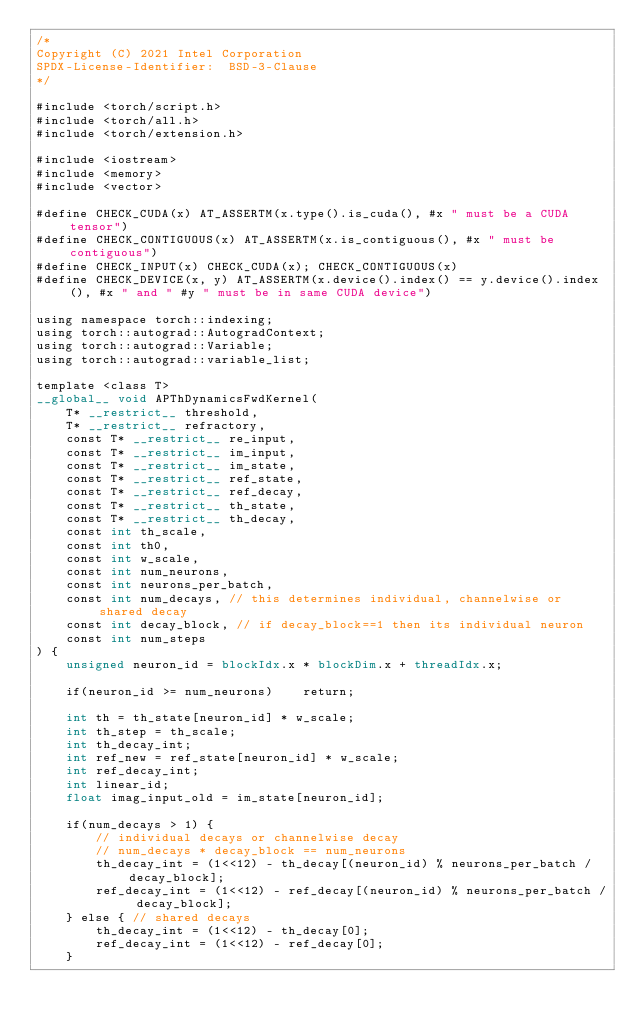Convert code to text. <code><loc_0><loc_0><loc_500><loc_500><_Cuda_>/*
Copyright (C) 2021 Intel Corporation
SPDX-License-Identifier:  BSD-3-Clause
*/

#include <torch/script.h>
#include <torch/all.h>
#include <torch/extension.h>

#include <iostream>
#include <memory>
#include <vector>

#define CHECK_CUDA(x) AT_ASSERTM(x.type().is_cuda(), #x " must be a CUDA tensor")
#define CHECK_CONTIGUOUS(x) AT_ASSERTM(x.is_contiguous(), #x " must be contiguous")
#define CHECK_INPUT(x) CHECK_CUDA(x); CHECK_CONTIGUOUS(x)
#define CHECK_DEVICE(x, y) AT_ASSERTM(x.device().index() == y.device().index(), #x " and " #y " must be in same CUDA device")

using namespace torch::indexing;
using torch::autograd::AutogradContext;
using torch::autograd::Variable;
using torch::autograd::variable_list;

template <class T>
__global__ void APThDynamicsFwdKernel(
    T* __restrict__ threshold,
    T* __restrict__ refractory,
    const T* __restrict__ re_input,
    const T* __restrict__ im_input,
    const T* __restrict__ im_state,
    const T* __restrict__ ref_state,
    const T* __restrict__ ref_decay,
    const T* __restrict__ th_state,
    const T* __restrict__ th_decay,
    const int th_scale,
    const int th0,
    const int w_scale,
    const int num_neurons,
    const int neurons_per_batch,
    const int num_decays, // this determines individual, channelwise or shared decay
    const int decay_block, // if decay_block==1 then its individual neuron
    const int num_steps
) {
    unsigned neuron_id = blockIdx.x * blockDim.x + threadIdx.x;

    if(neuron_id >= num_neurons)    return;

    int th = th_state[neuron_id] * w_scale;
    int th_step = th_scale;
    int th_decay_int;
    int ref_new = ref_state[neuron_id] * w_scale;
    int ref_decay_int;
    int linear_id; 
    float imag_input_old = im_state[neuron_id];

    if(num_decays > 1) {  
        // individual decays or channelwise decay
        // num_decays * decay_block == num_neurons
        th_decay_int = (1<<12) - th_decay[(neuron_id) % neurons_per_batch / decay_block];
        ref_decay_int = (1<<12) - ref_decay[(neuron_id) % neurons_per_batch / decay_block];
    } else { // shared decays
        th_decay_int = (1<<12) - th_decay[0];
        ref_decay_int = (1<<12) - ref_decay[0];
    }
</code> 